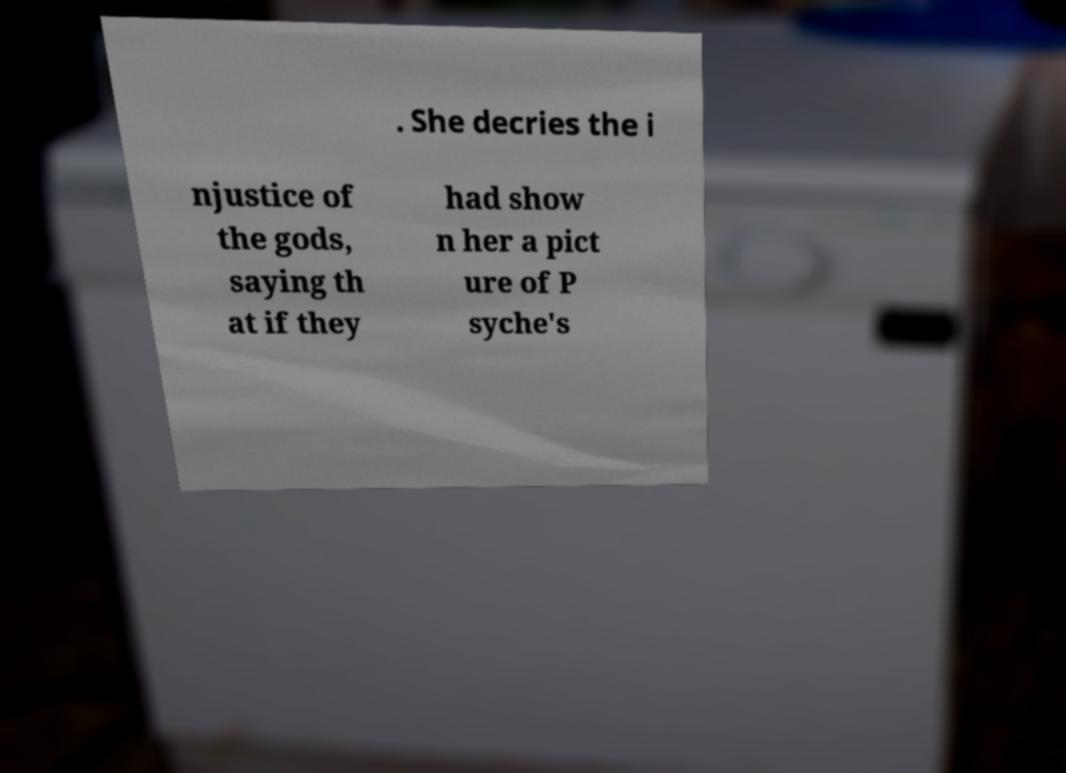I need the written content from this picture converted into text. Can you do that? . She decries the i njustice of the gods, saying th at if they had show n her a pict ure of P syche's 